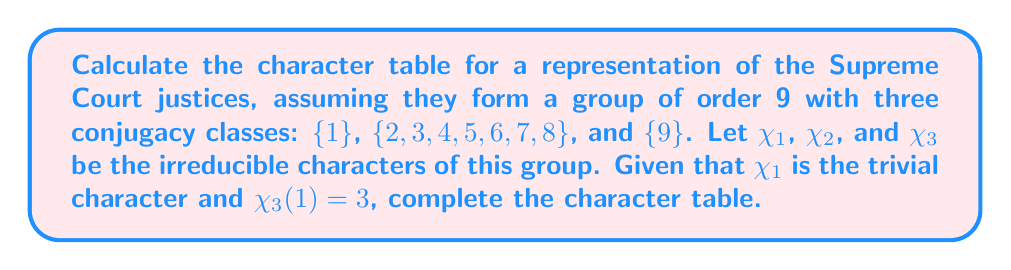Could you help me with this problem? 1) First, we set up the character table with the given information:

   $$\begin{array}{c|ccc}
   & \{1\} & \{2,3,4,5,6,7,8\} & \{9\} \\
   \hline
   \chi_1 & 1 & 1 & 1 \\
   \chi_2 & a & b & c \\
   \chi_3 & 3 & d & e
   \end{array}$$

2) We know that the sum of the squares of the dimensions of irreducible representations equals the order of the group:

   $$1^2 + a^2 + 3^2 = 9$$
   $$a^2 = 1$$
   $$a = 1$$ (since dimension is positive)

3) The orthogonality of characters gives us:

   $$1 \cdot 1 + 7b + c = 0$$
   $$1 \cdot 1 + 7d + e = 0$$

4) The column orthogonality relation for the first and third columns gives:

   $$1 \cdot 1 + 1 \cdot c + 3e = 0$$

5) From steps 3 and 4:

   $$7b + c = -1$$
   $$c + 3e = -1$$

6) The orthogonality of $\chi_2$ and $\chi_3$ gives:

   $$1 \cdot 3 + 7bd + ce = 0$$

7) Since $\chi_2$ is one-dimensional, its values must be roots of unity. Given $b$ appears 7 times, it must be 1 or -1. If $b = 1$, then $c = -8$ from step 5, which is impossible for a one-dimensional representation. Therefore, $b = -1$ and $c = 1$.

8) Substituting these values in the equation from step 3:

   $$1 \cdot 1 + 7d + e = 0$$
   $$7d + e = -1$$

9) Combining this with the equation from step 4:

   $$7d + e = -1$$
   $$e + 3e = -1$$
   $$4e = -1$$
   $$e = -\frac{1}{4}$$

10) Substituting back:

    $$7d - \frac{1}{4} = -1$$
    $$7d = -\frac{3}{4}$$
    $$d = -\frac{3}{28}$$

Therefore, the complete character table is:

$$\begin{array}{c|ccc}
& \{1\} & \{2,3,4,5,6,7,8\} & \{9\} \\
\hline
\chi_1 & 1 & 1 & 1 \\
\chi_2 & 1 & -1 & 1 \\
\chi_3 & 3 & -\frac{3}{28} & -\frac{1}{4}
\end{array}$$
Answer: $$\begin{array}{c|ccc}
& \{1\} & \{2,3,4,5,6,7,8\} & \{9\} \\
\hline
\chi_1 & 1 & 1 & 1 \\
\chi_2 & 1 & -1 & 1 \\
\chi_3 & 3 & -\frac{3}{28} & -\frac{1}{4}
\end{array}$$ 